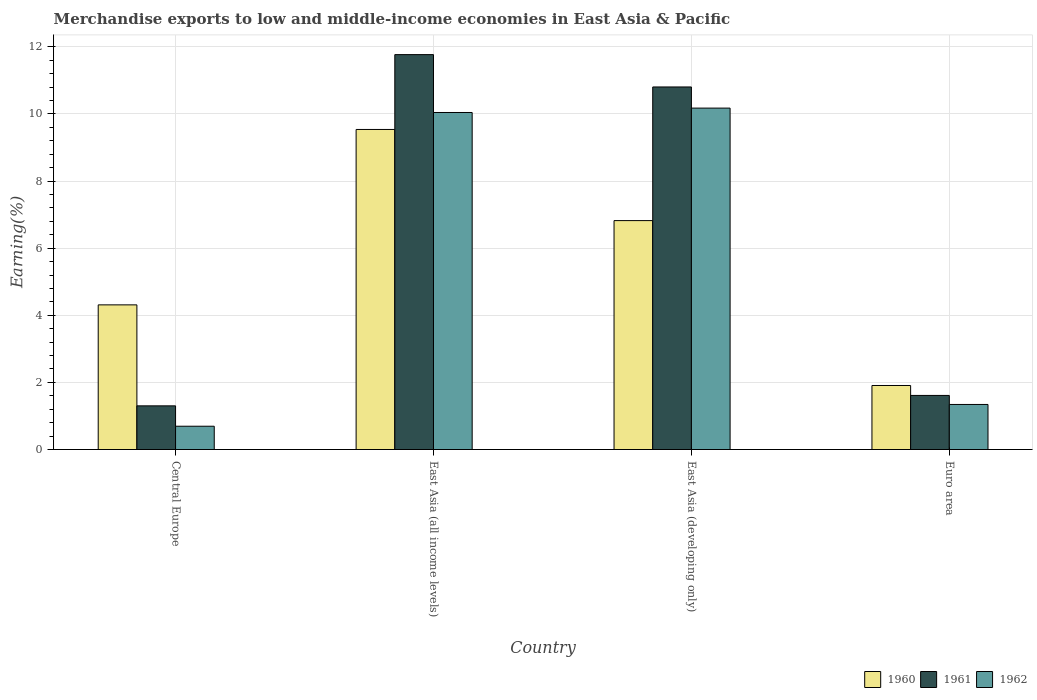How many different coloured bars are there?
Give a very brief answer. 3. How many groups of bars are there?
Ensure brevity in your answer.  4. Are the number of bars on each tick of the X-axis equal?
Your answer should be very brief. Yes. How many bars are there on the 3rd tick from the left?
Provide a short and direct response. 3. How many bars are there on the 1st tick from the right?
Offer a very short reply. 3. What is the label of the 2nd group of bars from the left?
Keep it short and to the point. East Asia (all income levels). In how many cases, is the number of bars for a given country not equal to the number of legend labels?
Offer a very short reply. 0. What is the percentage of amount earned from merchandise exports in 1960 in East Asia (developing only)?
Offer a terse response. 6.82. Across all countries, what is the maximum percentage of amount earned from merchandise exports in 1961?
Provide a short and direct response. 11.77. Across all countries, what is the minimum percentage of amount earned from merchandise exports in 1961?
Provide a short and direct response. 1.3. In which country was the percentage of amount earned from merchandise exports in 1962 maximum?
Make the answer very short. East Asia (developing only). What is the total percentage of amount earned from merchandise exports in 1961 in the graph?
Offer a terse response. 25.49. What is the difference between the percentage of amount earned from merchandise exports in 1960 in East Asia (all income levels) and that in East Asia (developing only)?
Provide a short and direct response. 2.72. What is the difference between the percentage of amount earned from merchandise exports in 1961 in East Asia (all income levels) and the percentage of amount earned from merchandise exports in 1960 in Euro area?
Your answer should be compact. 9.86. What is the average percentage of amount earned from merchandise exports in 1962 per country?
Provide a short and direct response. 5.56. What is the difference between the percentage of amount earned from merchandise exports of/in 1961 and percentage of amount earned from merchandise exports of/in 1962 in Central Europe?
Provide a short and direct response. 0.61. In how many countries, is the percentage of amount earned from merchandise exports in 1962 greater than 9.6 %?
Your answer should be compact. 2. What is the ratio of the percentage of amount earned from merchandise exports in 1961 in East Asia (developing only) to that in Euro area?
Your answer should be very brief. 6.7. What is the difference between the highest and the second highest percentage of amount earned from merchandise exports in 1962?
Give a very brief answer. -8.83. What is the difference between the highest and the lowest percentage of amount earned from merchandise exports in 1960?
Give a very brief answer. 7.63. In how many countries, is the percentage of amount earned from merchandise exports in 1962 greater than the average percentage of amount earned from merchandise exports in 1962 taken over all countries?
Make the answer very short. 2. Is the sum of the percentage of amount earned from merchandise exports in 1960 in Central Europe and East Asia (all income levels) greater than the maximum percentage of amount earned from merchandise exports in 1961 across all countries?
Keep it short and to the point. Yes. Are all the bars in the graph horizontal?
Your answer should be compact. No. What is the difference between two consecutive major ticks on the Y-axis?
Make the answer very short. 2. Does the graph contain any zero values?
Ensure brevity in your answer.  No. How many legend labels are there?
Offer a terse response. 3. How are the legend labels stacked?
Provide a succinct answer. Horizontal. What is the title of the graph?
Provide a succinct answer. Merchandise exports to low and middle-income economies in East Asia & Pacific. What is the label or title of the Y-axis?
Your answer should be compact. Earning(%). What is the Earning(%) of 1960 in Central Europe?
Keep it short and to the point. 4.31. What is the Earning(%) in 1961 in Central Europe?
Your answer should be compact. 1.3. What is the Earning(%) in 1962 in Central Europe?
Your answer should be very brief. 0.69. What is the Earning(%) in 1960 in East Asia (all income levels)?
Your answer should be very brief. 9.54. What is the Earning(%) in 1961 in East Asia (all income levels)?
Your response must be concise. 11.77. What is the Earning(%) in 1962 in East Asia (all income levels)?
Your response must be concise. 10.04. What is the Earning(%) of 1960 in East Asia (developing only)?
Give a very brief answer. 6.82. What is the Earning(%) of 1961 in East Asia (developing only)?
Provide a succinct answer. 10.8. What is the Earning(%) in 1962 in East Asia (developing only)?
Your answer should be very brief. 10.17. What is the Earning(%) of 1960 in Euro area?
Provide a succinct answer. 1.91. What is the Earning(%) in 1961 in Euro area?
Give a very brief answer. 1.61. What is the Earning(%) of 1962 in Euro area?
Offer a very short reply. 1.34. Across all countries, what is the maximum Earning(%) in 1960?
Provide a short and direct response. 9.54. Across all countries, what is the maximum Earning(%) of 1961?
Offer a terse response. 11.77. Across all countries, what is the maximum Earning(%) in 1962?
Offer a very short reply. 10.17. Across all countries, what is the minimum Earning(%) of 1960?
Offer a very short reply. 1.91. Across all countries, what is the minimum Earning(%) of 1961?
Keep it short and to the point. 1.3. Across all countries, what is the minimum Earning(%) in 1962?
Keep it short and to the point. 0.69. What is the total Earning(%) in 1960 in the graph?
Your answer should be compact. 22.58. What is the total Earning(%) in 1961 in the graph?
Provide a short and direct response. 25.49. What is the total Earning(%) of 1962 in the graph?
Your answer should be very brief. 22.25. What is the difference between the Earning(%) of 1960 in Central Europe and that in East Asia (all income levels)?
Give a very brief answer. -5.23. What is the difference between the Earning(%) in 1961 in Central Europe and that in East Asia (all income levels)?
Make the answer very short. -10.47. What is the difference between the Earning(%) of 1962 in Central Europe and that in East Asia (all income levels)?
Provide a short and direct response. -9.35. What is the difference between the Earning(%) in 1960 in Central Europe and that in East Asia (developing only)?
Make the answer very short. -2.51. What is the difference between the Earning(%) of 1961 in Central Europe and that in East Asia (developing only)?
Your response must be concise. -9.5. What is the difference between the Earning(%) of 1962 in Central Europe and that in East Asia (developing only)?
Make the answer very short. -9.48. What is the difference between the Earning(%) in 1960 in Central Europe and that in Euro area?
Provide a succinct answer. 2.4. What is the difference between the Earning(%) in 1961 in Central Europe and that in Euro area?
Offer a very short reply. -0.31. What is the difference between the Earning(%) of 1962 in Central Europe and that in Euro area?
Offer a very short reply. -0.65. What is the difference between the Earning(%) of 1960 in East Asia (all income levels) and that in East Asia (developing only)?
Offer a terse response. 2.72. What is the difference between the Earning(%) in 1961 in East Asia (all income levels) and that in East Asia (developing only)?
Your answer should be very brief. 0.96. What is the difference between the Earning(%) in 1962 in East Asia (all income levels) and that in East Asia (developing only)?
Offer a very short reply. -0.13. What is the difference between the Earning(%) in 1960 in East Asia (all income levels) and that in Euro area?
Offer a terse response. 7.63. What is the difference between the Earning(%) in 1961 in East Asia (all income levels) and that in Euro area?
Give a very brief answer. 10.16. What is the difference between the Earning(%) of 1962 in East Asia (all income levels) and that in Euro area?
Ensure brevity in your answer.  8.7. What is the difference between the Earning(%) of 1960 in East Asia (developing only) and that in Euro area?
Keep it short and to the point. 4.91. What is the difference between the Earning(%) in 1961 in East Asia (developing only) and that in Euro area?
Offer a terse response. 9.19. What is the difference between the Earning(%) of 1962 in East Asia (developing only) and that in Euro area?
Provide a succinct answer. 8.83. What is the difference between the Earning(%) of 1960 in Central Europe and the Earning(%) of 1961 in East Asia (all income levels)?
Your answer should be compact. -7.46. What is the difference between the Earning(%) in 1960 in Central Europe and the Earning(%) in 1962 in East Asia (all income levels)?
Your answer should be compact. -5.73. What is the difference between the Earning(%) of 1961 in Central Europe and the Earning(%) of 1962 in East Asia (all income levels)?
Your answer should be very brief. -8.74. What is the difference between the Earning(%) in 1960 in Central Europe and the Earning(%) in 1961 in East Asia (developing only)?
Keep it short and to the point. -6.49. What is the difference between the Earning(%) in 1960 in Central Europe and the Earning(%) in 1962 in East Asia (developing only)?
Your answer should be compact. -5.86. What is the difference between the Earning(%) of 1961 in Central Europe and the Earning(%) of 1962 in East Asia (developing only)?
Your answer should be very brief. -8.87. What is the difference between the Earning(%) of 1960 in Central Europe and the Earning(%) of 1961 in Euro area?
Give a very brief answer. 2.7. What is the difference between the Earning(%) of 1960 in Central Europe and the Earning(%) of 1962 in Euro area?
Ensure brevity in your answer.  2.97. What is the difference between the Earning(%) of 1961 in Central Europe and the Earning(%) of 1962 in Euro area?
Your response must be concise. -0.04. What is the difference between the Earning(%) in 1960 in East Asia (all income levels) and the Earning(%) in 1961 in East Asia (developing only)?
Provide a succinct answer. -1.27. What is the difference between the Earning(%) of 1960 in East Asia (all income levels) and the Earning(%) of 1962 in East Asia (developing only)?
Provide a succinct answer. -0.64. What is the difference between the Earning(%) in 1961 in East Asia (all income levels) and the Earning(%) in 1962 in East Asia (developing only)?
Provide a succinct answer. 1.59. What is the difference between the Earning(%) of 1960 in East Asia (all income levels) and the Earning(%) of 1961 in Euro area?
Provide a succinct answer. 7.93. What is the difference between the Earning(%) of 1960 in East Asia (all income levels) and the Earning(%) of 1962 in Euro area?
Provide a succinct answer. 8.2. What is the difference between the Earning(%) in 1961 in East Asia (all income levels) and the Earning(%) in 1962 in Euro area?
Make the answer very short. 10.43. What is the difference between the Earning(%) in 1960 in East Asia (developing only) and the Earning(%) in 1961 in Euro area?
Your answer should be compact. 5.21. What is the difference between the Earning(%) in 1960 in East Asia (developing only) and the Earning(%) in 1962 in Euro area?
Your response must be concise. 5.48. What is the difference between the Earning(%) of 1961 in East Asia (developing only) and the Earning(%) of 1962 in Euro area?
Your answer should be very brief. 9.46. What is the average Earning(%) of 1960 per country?
Your answer should be compact. 5.64. What is the average Earning(%) of 1961 per country?
Offer a very short reply. 6.37. What is the average Earning(%) in 1962 per country?
Your response must be concise. 5.56. What is the difference between the Earning(%) of 1960 and Earning(%) of 1961 in Central Europe?
Your answer should be very brief. 3.01. What is the difference between the Earning(%) of 1960 and Earning(%) of 1962 in Central Europe?
Offer a very short reply. 3.62. What is the difference between the Earning(%) in 1961 and Earning(%) in 1962 in Central Europe?
Ensure brevity in your answer.  0.61. What is the difference between the Earning(%) in 1960 and Earning(%) in 1961 in East Asia (all income levels)?
Offer a terse response. -2.23. What is the difference between the Earning(%) of 1960 and Earning(%) of 1962 in East Asia (all income levels)?
Your answer should be compact. -0.51. What is the difference between the Earning(%) in 1961 and Earning(%) in 1962 in East Asia (all income levels)?
Give a very brief answer. 1.72. What is the difference between the Earning(%) of 1960 and Earning(%) of 1961 in East Asia (developing only)?
Provide a succinct answer. -3.98. What is the difference between the Earning(%) of 1960 and Earning(%) of 1962 in East Asia (developing only)?
Your answer should be compact. -3.35. What is the difference between the Earning(%) of 1961 and Earning(%) of 1962 in East Asia (developing only)?
Your answer should be compact. 0.63. What is the difference between the Earning(%) in 1960 and Earning(%) in 1961 in Euro area?
Your answer should be compact. 0.3. What is the difference between the Earning(%) in 1960 and Earning(%) in 1962 in Euro area?
Provide a succinct answer. 0.57. What is the difference between the Earning(%) in 1961 and Earning(%) in 1962 in Euro area?
Ensure brevity in your answer.  0.27. What is the ratio of the Earning(%) of 1960 in Central Europe to that in East Asia (all income levels)?
Give a very brief answer. 0.45. What is the ratio of the Earning(%) of 1961 in Central Europe to that in East Asia (all income levels)?
Keep it short and to the point. 0.11. What is the ratio of the Earning(%) of 1962 in Central Europe to that in East Asia (all income levels)?
Ensure brevity in your answer.  0.07. What is the ratio of the Earning(%) of 1960 in Central Europe to that in East Asia (developing only)?
Keep it short and to the point. 0.63. What is the ratio of the Earning(%) of 1961 in Central Europe to that in East Asia (developing only)?
Offer a terse response. 0.12. What is the ratio of the Earning(%) in 1962 in Central Europe to that in East Asia (developing only)?
Make the answer very short. 0.07. What is the ratio of the Earning(%) in 1960 in Central Europe to that in Euro area?
Give a very brief answer. 2.26. What is the ratio of the Earning(%) in 1961 in Central Europe to that in Euro area?
Provide a succinct answer. 0.81. What is the ratio of the Earning(%) of 1962 in Central Europe to that in Euro area?
Provide a succinct answer. 0.52. What is the ratio of the Earning(%) of 1960 in East Asia (all income levels) to that in East Asia (developing only)?
Ensure brevity in your answer.  1.4. What is the ratio of the Earning(%) of 1961 in East Asia (all income levels) to that in East Asia (developing only)?
Provide a succinct answer. 1.09. What is the ratio of the Earning(%) in 1962 in East Asia (all income levels) to that in East Asia (developing only)?
Give a very brief answer. 0.99. What is the ratio of the Earning(%) in 1960 in East Asia (all income levels) to that in Euro area?
Keep it short and to the point. 5. What is the ratio of the Earning(%) in 1961 in East Asia (all income levels) to that in Euro area?
Give a very brief answer. 7.3. What is the ratio of the Earning(%) of 1962 in East Asia (all income levels) to that in Euro area?
Your answer should be very brief. 7.48. What is the ratio of the Earning(%) in 1960 in East Asia (developing only) to that in Euro area?
Your answer should be very brief. 3.58. What is the ratio of the Earning(%) in 1961 in East Asia (developing only) to that in Euro area?
Your response must be concise. 6.7. What is the ratio of the Earning(%) in 1962 in East Asia (developing only) to that in Euro area?
Make the answer very short. 7.58. What is the difference between the highest and the second highest Earning(%) of 1960?
Provide a short and direct response. 2.72. What is the difference between the highest and the second highest Earning(%) of 1961?
Ensure brevity in your answer.  0.96. What is the difference between the highest and the second highest Earning(%) of 1962?
Make the answer very short. 0.13. What is the difference between the highest and the lowest Earning(%) of 1960?
Give a very brief answer. 7.63. What is the difference between the highest and the lowest Earning(%) of 1961?
Offer a very short reply. 10.47. What is the difference between the highest and the lowest Earning(%) of 1962?
Your response must be concise. 9.48. 